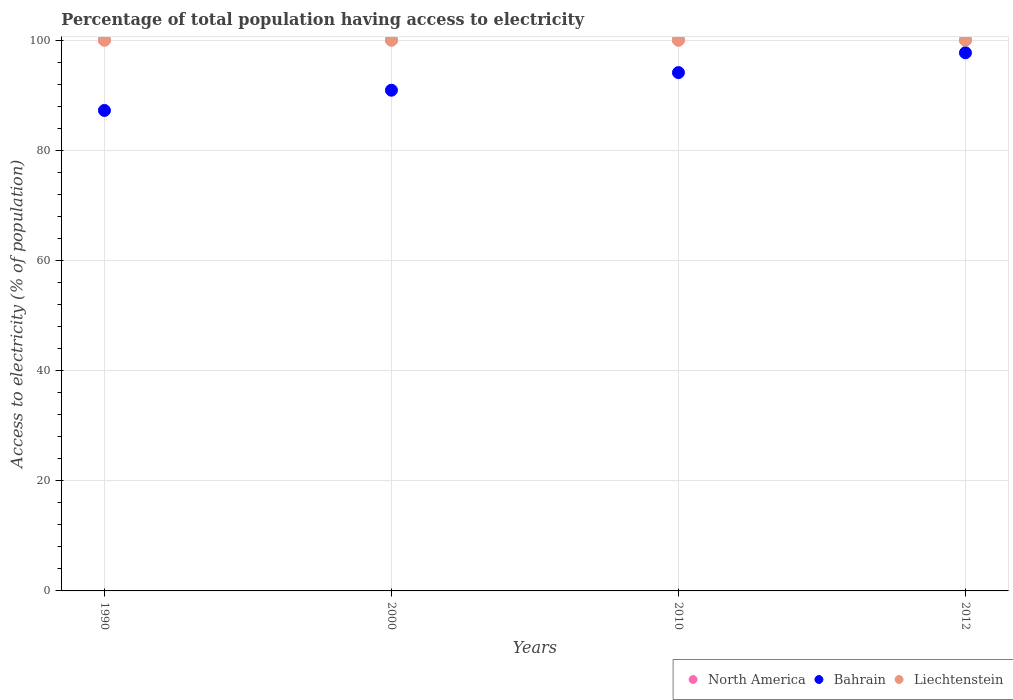How many different coloured dotlines are there?
Your answer should be compact. 3. What is the percentage of population that have access to electricity in Bahrain in 2000?
Your answer should be very brief. 90.9. Across all years, what is the maximum percentage of population that have access to electricity in North America?
Make the answer very short. 100. Across all years, what is the minimum percentage of population that have access to electricity in North America?
Make the answer very short. 100. In which year was the percentage of population that have access to electricity in Bahrain maximum?
Your answer should be very brief. 2012. In which year was the percentage of population that have access to electricity in Bahrain minimum?
Your response must be concise. 1990. What is the total percentage of population that have access to electricity in Liechtenstein in the graph?
Offer a very short reply. 400. What is the difference between the percentage of population that have access to electricity in Bahrain in 1990 and that in 2010?
Offer a very short reply. -6.87. What is the difference between the percentage of population that have access to electricity in Liechtenstein in 2012 and the percentage of population that have access to electricity in Bahrain in 2010?
Offer a very short reply. 5.9. What is the average percentage of population that have access to electricity in Bahrain per year?
Ensure brevity in your answer.  92.48. In the year 2000, what is the difference between the percentage of population that have access to electricity in Liechtenstein and percentage of population that have access to electricity in Bahrain?
Your response must be concise. 9.1. In how many years, is the percentage of population that have access to electricity in Bahrain greater than 44 %?
Offer a terse response. 4. What is the difference between the highest and the lowest percentage of population that have access to electricity in Liechtenstein?
Provide a succinct answer. 0. In how many years, is the percentage of population that have access to electricity in North America greater than the average percentage of population that have access to electricity in North America taken over all years?
Your response must be concise. 0. Is the percentage of population that have access to electricity in Liechtenstein strictly greater than the percentage of population that have access to electricity in North America over the years?
Make the answer very short. No. How many dotlines are there?
Your response must be concise. 3. How many years are there in the graph?
Your answer should be very brief. 4. What is the difference between two consecutive major ticks on the Y-axis?
Your answer should be very brief. 20. Are the values on the major ticks of Y-axis written in scientific E-notation?
Offer a very short reply. No. Does the graph contain grids?
Your answer should be very brief. Yes. Where does the legend appear in the graph?
Provide a short and direct response. Bottom right. How are the legend labels stacked?
Your answer should be compact. Horizontal. What is the title of the graph?
Your answer should be compact. Percentage of total population having access to electricity. Does "St. Lucia" appear as one of the legend labels in the graph?
Provide a succinct answer. No. What is the label or title of the Y-axis?
Your answer should be very brief. Access to electricity (% of population). What is the Access to electricity (% of population) in North America in 1990?
Ensure brevity in your answer.  100. What is the Access to electricity (% of population) in Bahrain in 1990?
Your response must be concise. 87.23. What is the Access to electricity (% of population) of Liechtenstein in 1990?
Your answer should be compact. 100. What is the Access to electricity (% of population) of Bahrain in 2000?
Give a very brief answer. 90.9. What is the Access to electricity (% of population) in North America in 2010?
Your response must be concise. 100. What is the Access to electricity (% of population) in Bahrain in 2010?
Your answer should be compact. 94.1. What is the Access to electricity (% of population) in Bahrain in 2012?
Give a very brief answer. 97.7. What is the Access to electricity (% of population) of Liechtenstein in 2012?
Give a very brief answer. 100. Across all years, what is the maximum Access to electricity (% of population) of Bahrain?
Your response must be concise. 97.7. Across all years, what is the minimum Access to electricity (% of population) in Bahrain?
Offer a terse response. 87.23. Across all years, what is the minimum Access to electricity (% of population) of Liechtenstein?
Offer a very short reply. 100. What is the total Access to electricity (% of population) of Bahrain in the graph?
Provide a succinct answer. 369.92. What is the total Access to electricity (% of population) of Liechtenstein in the graph?
Your response must be concise. 400. What is the difference between the Access to electricity (% of population) in North America in 1990 and that in 2000?
Keep it short and to the point. 0. What is the difference between the Access to electricity (% of population) in Bahrain in 1990 and that in 2000?
Ensure brevity in your answer.  -3.67. What is the difference between the Access to electricity (% of population) in Bahrain in 1990 and that in 2010?
Provide a short and direct response. -6.87. What is the difference between the Access to electricity (% of population) in Liechtenstein in 1990 and that in 2010?
Offer a very short reply. 0. What is the difference between the Access to electricity (% of population) of Bahrain in 1990 and that in 2012?
Make the answer very short. -10.47. What is the difference between the Access to electricity (% of population) in North America in 2000 and that in 2010?
Make the answer very short. 0. What is the difference between the Access to electricity (% of population) of Bahrain in 2000 and that in 2010?
Make the answer very short. -3.2. What is the difference between the Access to electricity (% of population) in North America in 2000 and that in 2012?
Give a very brief answer. 0. What is the difference between the Access to electricity (% of population) of Bahrain in 2000 and that in 2012?
Ensure brevity in your answer.  -6.8. What is the difference between the Access to electricity (% of population) in North America in 2010 and that in 2012?
Your answer should be very brief. 0. What is the difference between the Access to electricity (% of population) in Bahrain in 2010 and that in 2012?
Your response must be concise. -3.6. What is the difference between the Access to electricity (% of population) in Liechtenstein in 2010 and that in 2012?
Ensure brevity in your answer.  0. What is the difference between the Access to electricity (% of population) in North America in 1990 and the Access to electricity (% of population) in Bahrain in 2000?
Offer a terse response. 9.1. What is the difference between the Access to electricity (% of population) of North America in 1990 and the Access to electricity (% of population) of Liechtenstein in 2000?
Make the answer very short. 0. What is the difference between the Access to electricity (% of population) of Bahrain in 1990 and the Access to electricity (% of population) of Liechtenstein in 2000?
Make the answer very short. -12.77. What is the difference between the Access to electricity (% of population) in Bahrain in 1990 and the Access to electricity (% of population) in Liechtenstein in 2010?
Provide a succinct answer. -12.77. What is the difference between the Access to electricity (% of population) in North America in 1990 and the Access to electricity (% of population) in Bahrain in 2012?
Your answer should be compact. 2.3. What is the difference between the Access to electricity (% of population) of North America in 1990 and the Access to electricity (% of population) of Liechtenstein in 2012?
Your answer should be compact. 0. What is the difference between the Access to electricity (% of population) of Bahrain in 1990 and the Access to electricity (% of population) of Liechtenstein in 2012?
Provide a short and direct response. -12.77. What is the difference between the Access to electricity (% of population) in North America in 2000 and the Access to electricity (% of population) in Liechtenstein in 2010?
Ensure brevity in your answer.  0. What is the difference between the Access to electricity (% of population) in Bahrain in 2000 and the Access to electricity (% of population) in Liechtenstein in 2010?
Provide a succinct answer. -9.1. What is the difference between the Access to electricity (% of population) in North America in 2000 and the Access to electricity (% of population) in Bahrain in 2012?
Make the answer very short. 2.3. What is the difference between the Access to electricity (% of population) of North America in 2000 and the Access to electricity (% of population) of Liechtenstein in 2012?
Offer a very short reply. 0. What is the difference between the Access to electricity (% of population) of Bahrain in 2000 and the Access to electricity (% of population) of Liechtenstein in 2012?
Offer a terse response. -9.1. What is the difference between the Access to electricity (% of population) in North America in 2010 and the Access to electricity (% of population) in Bahrain in 2012?
Offer a terse response. 2.3. What is the difference between the Access to electricity (% of population) of Bahrain in 2010 and the Access to electricity (% of population) of Liechtenstein in 2012?
Your response must be concise. -5.9. What is the average Access to electricity (% of population) of North America per year?
Ensure brevity in your answer.  100. What is the average Access to electricity (% of population) of Bahrain per year?
Provide a short and direct response. 92.48. In the year 1990, what is the difference between the Access to electricity (% of population) of North America and Access to electricity (% of population) of Bahrain?
Provide a succinct answer. 12.77. In the year 1990, what is the difference between the Access to electricity (% of population) in Bahrain and Access to electricity (% of population) in Liechtenstein?
Your answer should be very brief. -12.77. In the year 2000, what is the difference between the Access to electricity (% of population) in North America and Access to electricity (% of population) in Bahrain?
Your response must be concise. 9.1. In the year 2000, what is the difference between the Access to electricity (% of population) in North America and Access to electricity (% of population) in Liechtenstein?
Offer a terse response. 0. In the year 2000, what is the difference between the Access to electricity (% of population) of Bahrain and Access to electricity (% of population) of Liechtenstein?
Ensure brevity in your answer.  -9.1. In the year 2012, what is the difference between the Access to electricity (% of population) of North America and Access to electricity (% of population) of Bahrain?
Your answer should be very brief. 2.3. In the year 2012, what is the difference between the Access to electricity (% of population) in North America and Access to electricity (% of population) in Liechtenstein?
Provide a succinct answer. 0. In the year 2012, what is the difference between the Access to electricity (% of population) in Bahrain and Access to electricity (% of population) in Liechtenstein?
Keep it short and to the point. -2.3. What is the ratio of the Access to electricity (% of population) in North America in 1990 to that in 2000?
Make the answer very short. 1. What is the ratio of the Access to electricity (% of population) in Bahrain in 1990 to that in 2000?
Keep it short and to the point. 0.96. What is the ratio of the Access to electricity (% of population) in Liechtenstein in 1990 to that in 2000?
Ensure brevity in your answer.  1. What is the ratio of the Access to electricity (% of population) of North America in 1990 to that in 2010?
Make the answer very short. 1. What is the ratio of the Access to electricity (% of population) in Bahrain in 1990 to that in 2010?
Offer a very short reply. 0.93. What is the ratio of the Access to electricity (% of population) in North America in 1990 to that in 2012?
Make the answer very short. 1. What is the ratio of the Access to electricity (% of population) of Bahrain in 1990 to that in 2012?
Provide a succinct answer. 0.89. What is the ratio of the Access to electricity (% of population) of North America in 2000 to that in 2010?
Keep it short and to the point. 1. What is the ratio of the Access to electricity (% of population) of Bahrain in 2000 to that in 2010?
Keep it short and to the point. 0.97. What is the ratio of the Access to electricity (% of population) of North America in 2000 to that in 2012?
Offer a terse response. 1. What is the ratio of the Access to electricity (% of population) of Bahrain in 2000 to that in 2012?
Offer a terse response. 0.93. What is the ratio of the Access to electricity (% of population) of North America in 2010 to that in 2012?
Make the answer very short. 1. What is the ratio of the Access to electricity (% of population) of Bahrain in 2010 to that in 2012?
Ensure brevity in your answer.  0.96. What is the ratio of the Access to electricity (% of population) of Liechtenstein in 2010 to that in 2012?
Your answer should be very brief. 1. What is the difference between the highest and the second highest Access to electricity (% of population) of North America?
Your response must be concise. 0. What is the difference between the highest and the second highest Access to electricity (% of population) of Bahrain?
Your answer should be very brief. 3.6. What is the difference between the highest and the second highest Access to electricity (% of population) in Liechtenstein?
Provide a short and direct response. 0. What is the difference between the highest and the lowest Access to electricity (% of population) in Bahrain?
Keep it short and to the point. 10.47. 